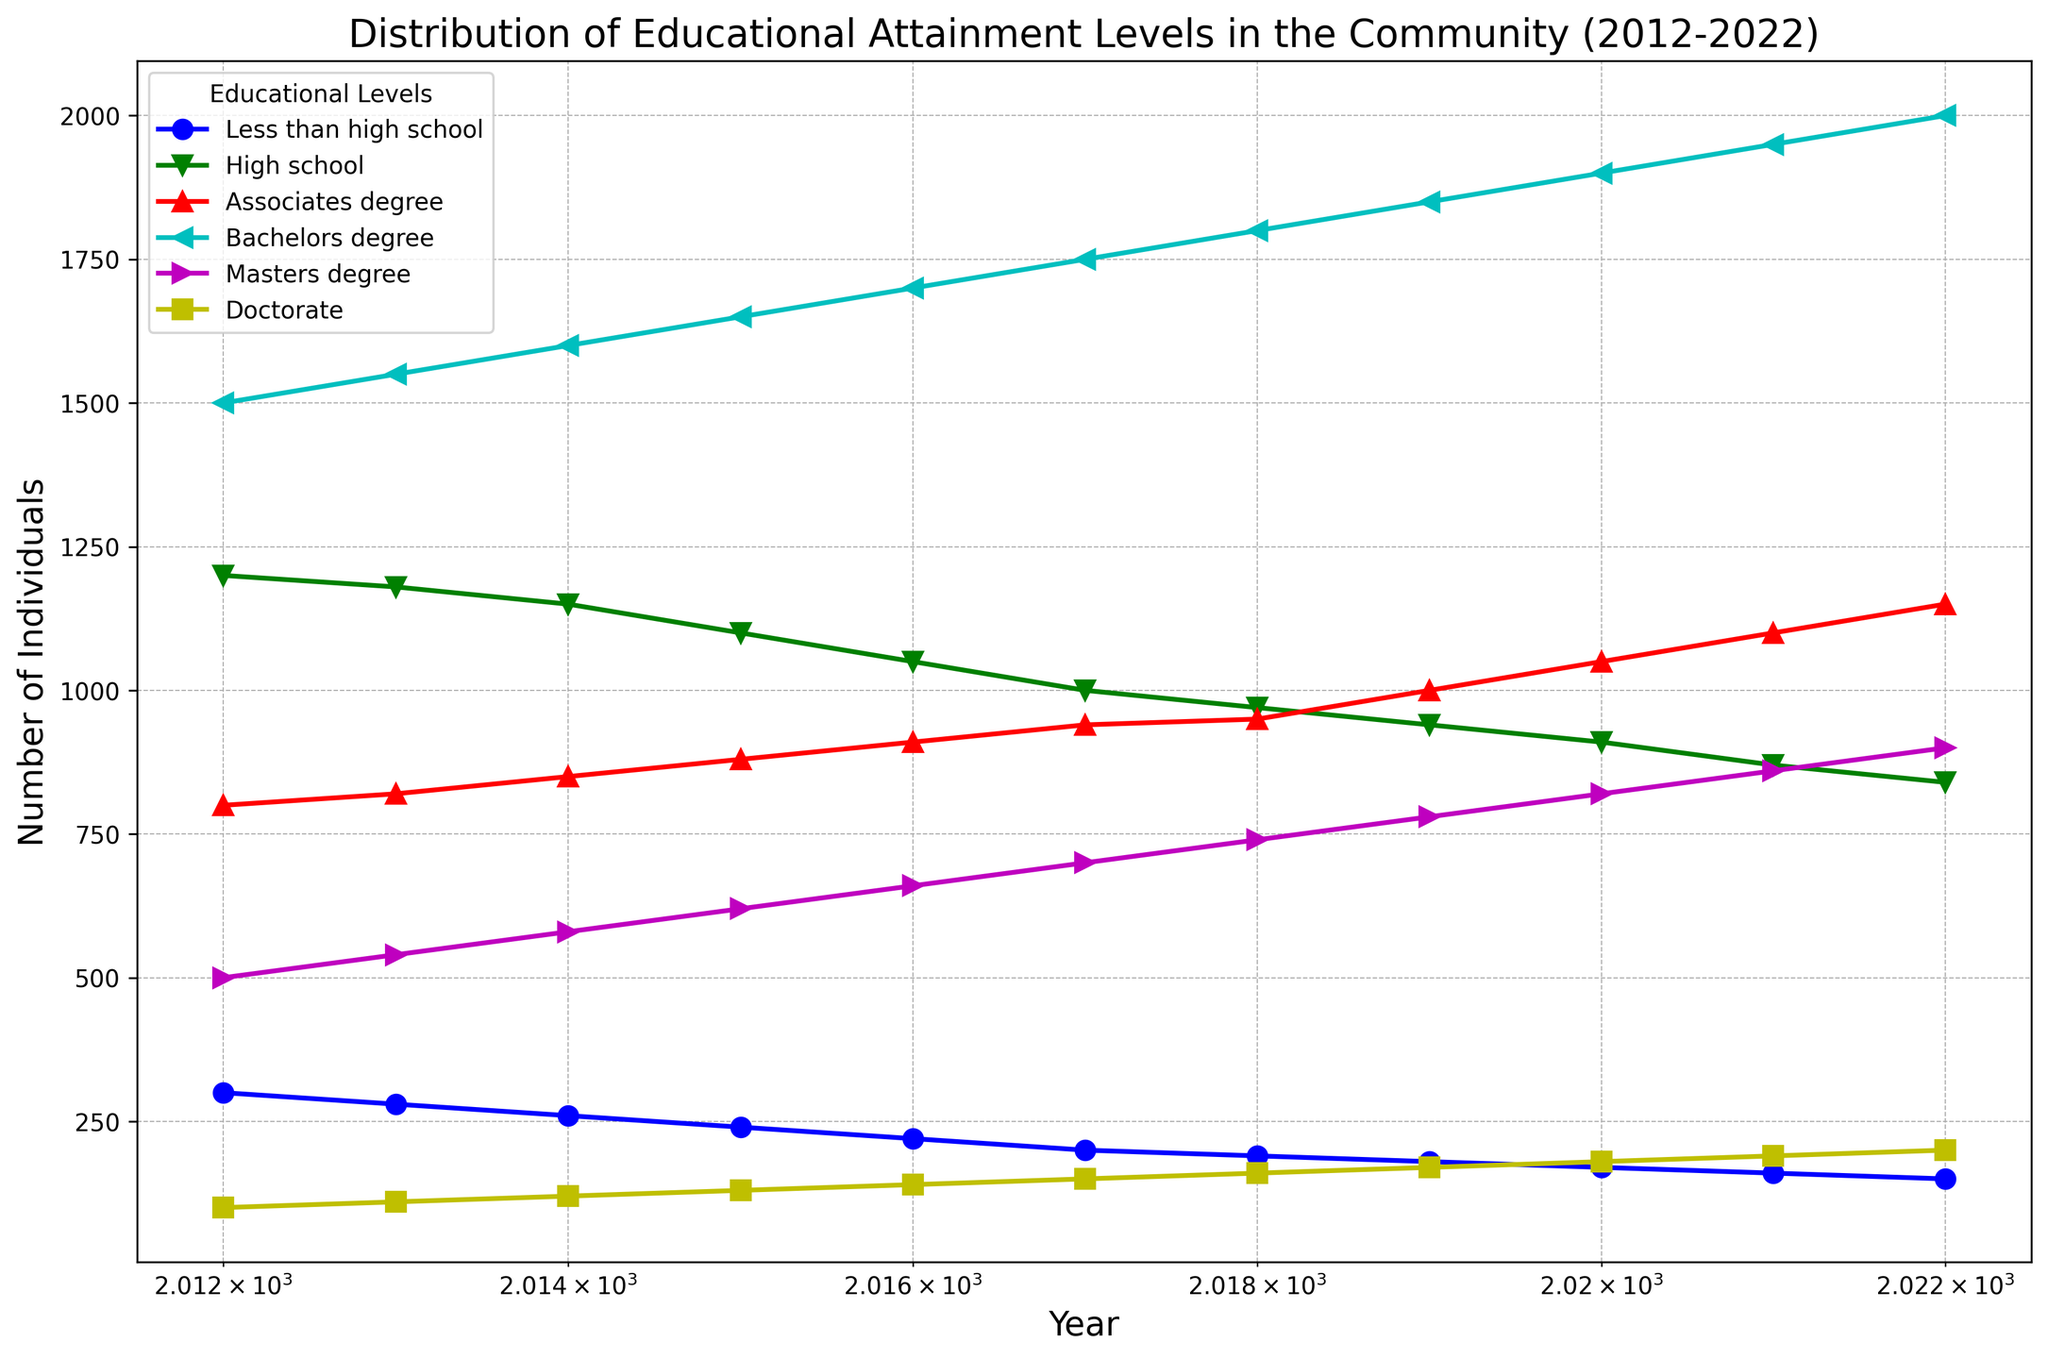Which educational level saw the highest number of individuals in 2022? Look at the corresponding points on the log scale for each educational level in 2022. The 'Bachelors degree' has the highest value.
Answer: Bachelors degree How many individuals had a master's degree in 2015 and how does that compare to 2022? In 2015, the master's degree count is 620. In 2022, it's 900. So, there's an increase of 280.
Answer: 620 in 2015, 900 in 2022, increase of 280 What's the difference in the number of people with less than a high school diploma between 2012 and 2022? Subtract the number of people with less than a high school diploma in 2022 (150) from that in 2012 (300). The difference is 150.
Answer: 150 Which year had the highest number of individuals with an associate's degree? By observing the log-scaled plot for the associate's degree line, the highest point is in 2022.
Answer: 2022 Which educational level exhibited the most consistent growth over the decade? Review the visual trend lines in the graph. The 'Bachelors degree' demonstrates the most consistent upward growth.
Answer: Bachelors degree What is the total number of individuals in the community with any level of educational attainment in 2016? Sum the values for all educational levels in 2016: 220 (less_than_high_school) + 1050 (high_school) + 910 (associates_degree) + 1700 (bachelors_degree) + 660 (masters_degree) + 140 (doctorate) = 4680.
Answer: 4680 By how much did the number of people with a doctorate degree increase from 2012 to 2022? Subtract the number of individuals with a doctorate in 2012 (100) from that in 2022 (200). The increase is 100.
Answer: 100 Which educational level had the smallest population in 2020? Check the educational level lines for 2020. The 'Less than high school' level is the smallest.
Answer: Less than high school Comparing 2014 and 2021, which educational attainment level had the most significant increase in its population? Calculate the differences for each educational level between 2014 and 2021. The largest increase can be seen in 'Bachelors degree' with an increase from 1600 to 1950, amounting to 350.
Answer: Bachelors degree What is the median number of individuals with a high school diploma for the years 2012 to 2022? Arrange the high school diploma numbers in ascending order: 840, 870, 910, 940, 970, 1000, 1050, 1100, 1150, 1180, 1200. The median is the 6th value, which is 1000.
Answer: 1000 